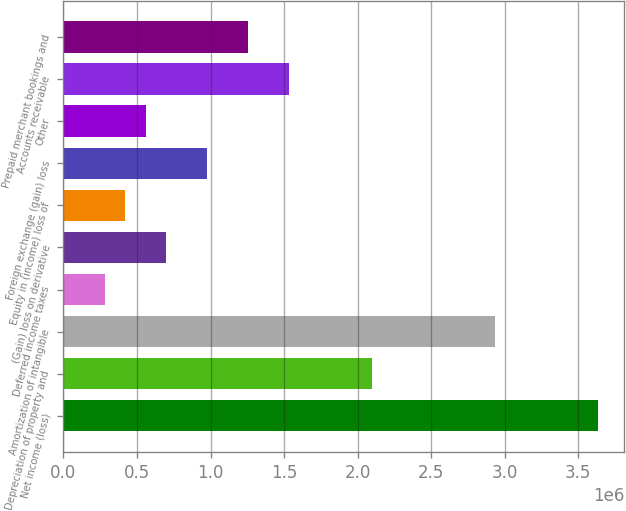Convert chart. <chart><loc_0><loc_0><loc_500><loc_500><bar_chart><fcel>Net income (loss)<fcel>Depreciation of property and<fcel>Amortization of intangible<fcel>Deferred income taxes<fcel>(Gain) loss on derivative<fcel>Equity in (income) loss of<fcel>Foreign exchange (gain) loss<fcel>Other<fcel>Accounts receivable<fcel>Prepaid merchant bookings and<nl><fcel>3.6313e+06<fcel>2.09534e+06<fcel>2.93313e+06<fcel>280110<fcel>699008<fcel>419743<fcel>978274<fcel>559376<fcel>1.53681e+06<fcel>1.25754e+06<nl></chart> 